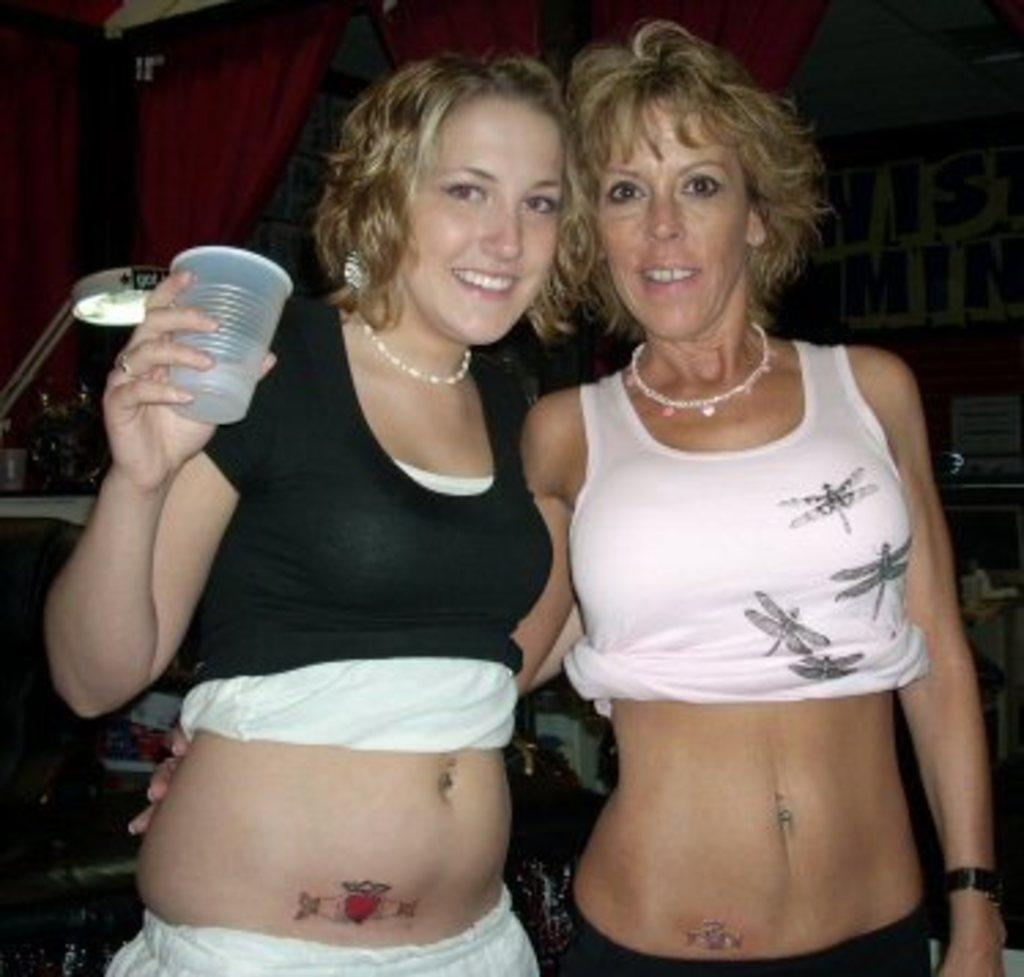How many women are in the image? There are two women in the image. What is the facial expression of the women? Both women are smiling. What can be seen in the background of the image? There are curtains visible in the image. Where is the light coming from in the image? There is light on the left side of the image. What is the woman on the left side of the image holding? The woman on the left side of the image is holding a glass. What type of muscle is being flexed by the woman on the right side of the image? There is no indication in the image that either woman is flexing a muscle. 